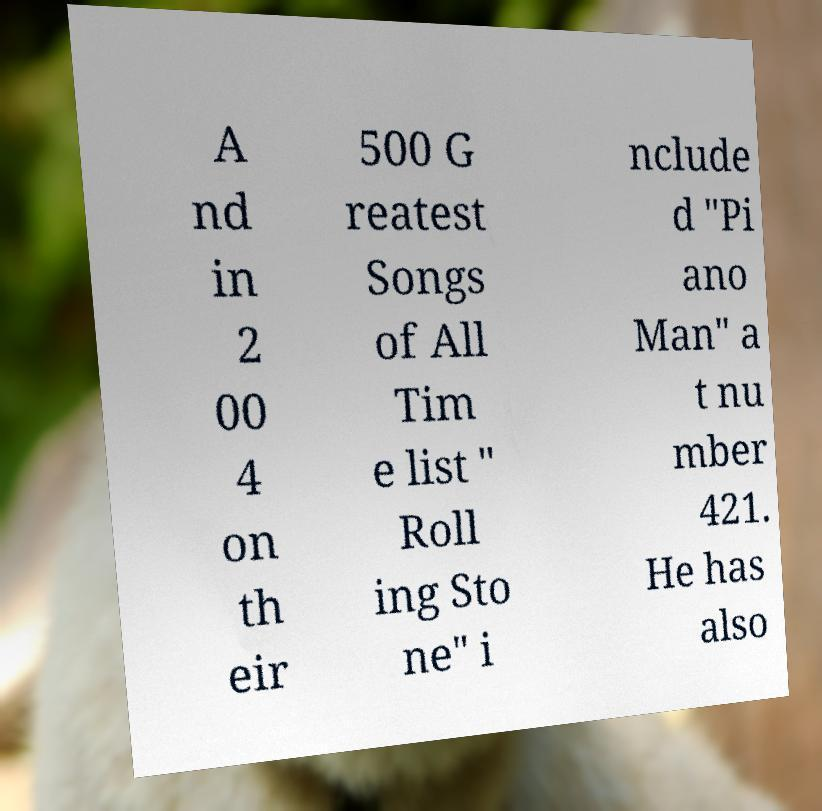Can you read and provide the text displayed in the image?This photo seems to have some interesting text. Can you extract and type it out for me? A nd in 2 00 4 on th eir 500 G reatest Songs of All Tim e list " Roll ing Sto ne" i nclude d "Pi ano Man" a t nu mber 421. He has also 